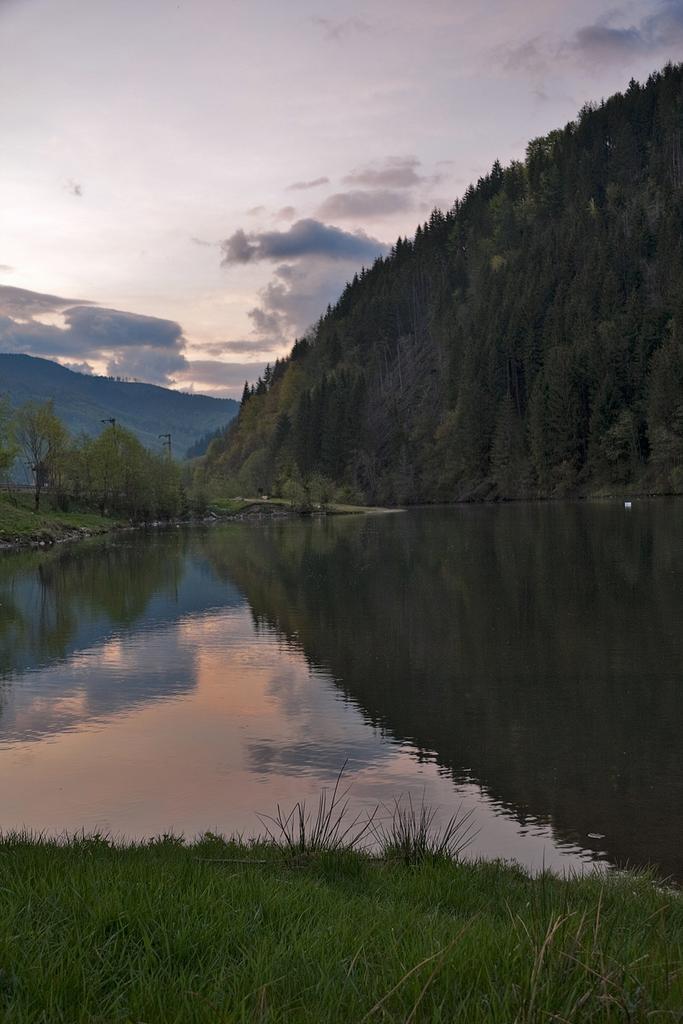Can you describe this image briefly? In this picture we can see water, grass, trees, and mountain. In the background there is sky with clouds. 